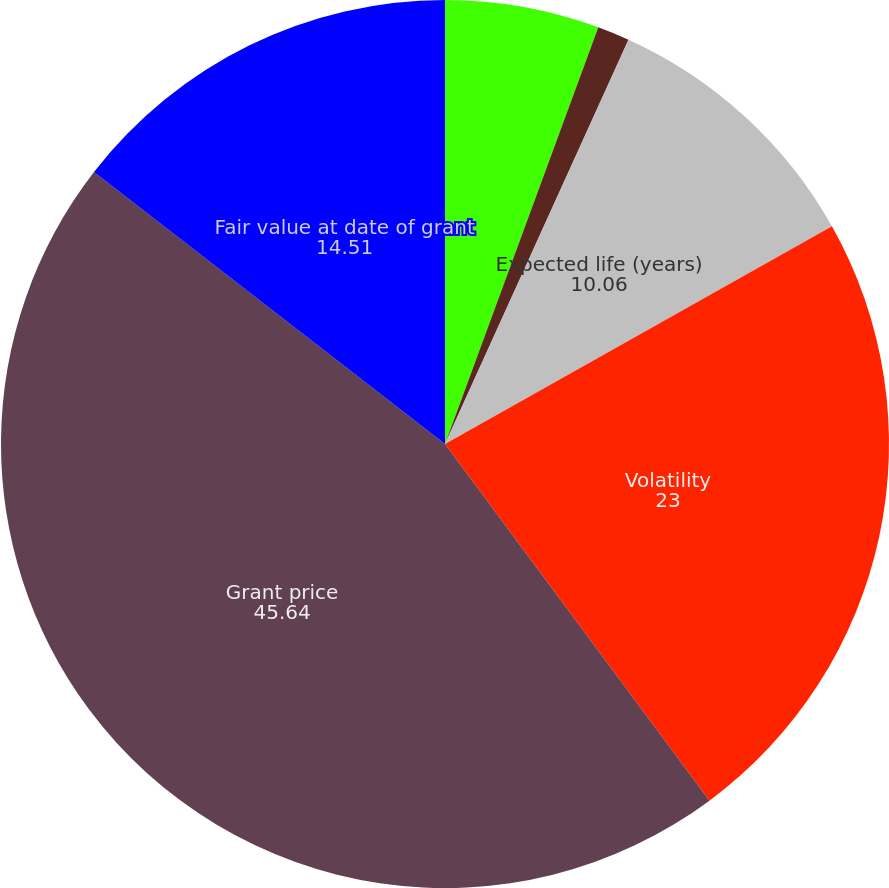Convert chart to OTSL. <chart><loc_0><loc_0><loc_500><loc_500><pie_chart><fcel>Risk-free interest rate<fcel>Dividend yield<fcel>Expected life (years)<fcel>Volatility<fcel>Grant price<fcel>Fair value at date of grant<nl><fcel>5.61%<fcel>1.17%<fcel>10.06%<fcel>23.0%<fcel>45.64%<fcel>14.51%<nl></chart> 